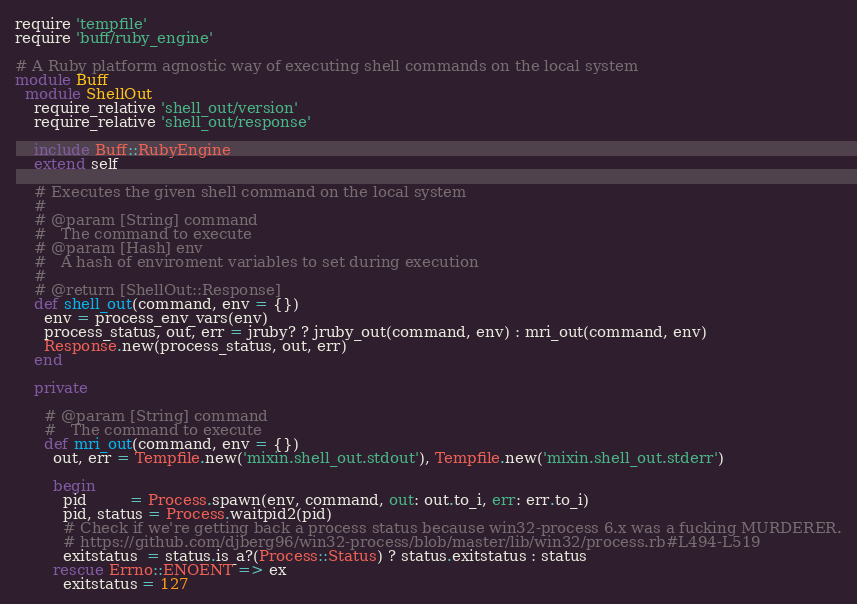Convert code to text. <code><loc_0><loc_0><loc_500><loc_500><_Ruby_>require 'tempfile'
require 'buff/ruby_engine'

# A Ruby platform agnostic way of executing shell commands on the local system
module Buff
  module ShellOut
    require_relative 'shell_out/version'
    require_relative 'shell_out/response'

    include Buff::RubyEngine
    extend self

    # Executes the given shell command on the local system
    #
    # @param [String] command
    #   The command to execute
    # @param [Hash] env
    #   A hash of enviroment variables to set during execution
    #
    # @return [ShellOut::Response]
    def shell_out(command, env = {})
      env = process_env_vars(env)
      process_status, out, err = jruby? ? jruby_out(command, env) : mri_out(command, env)
      Response.new(process_status, out, err)
    end

    private

      # @param [String] command
      #   The command to execute
      def mri_out(command, env = {})
        out, err = Tempfile.new('mixin.shell_out.stdout'), Tempfile.new('mixin.shell_out.stderr')

        begin
          pid         = Process.spawn(env, command, out: out.to_i, err: err.to_i)
          pid, status = Process.waitpid2(pid)
          # Check if we're getting back a process status because win32-process 6.x was a fucking MURDERER.
          # https://github.com/djberg96/win32-process/blob/master/lib/win32/process.rb#L494-L519
          exitstatus  = status.is_a?(Process::Status) ? status.exitstatus : status
        rescue Errno::ENOENT => ex
          exitstatus = 127</code> 